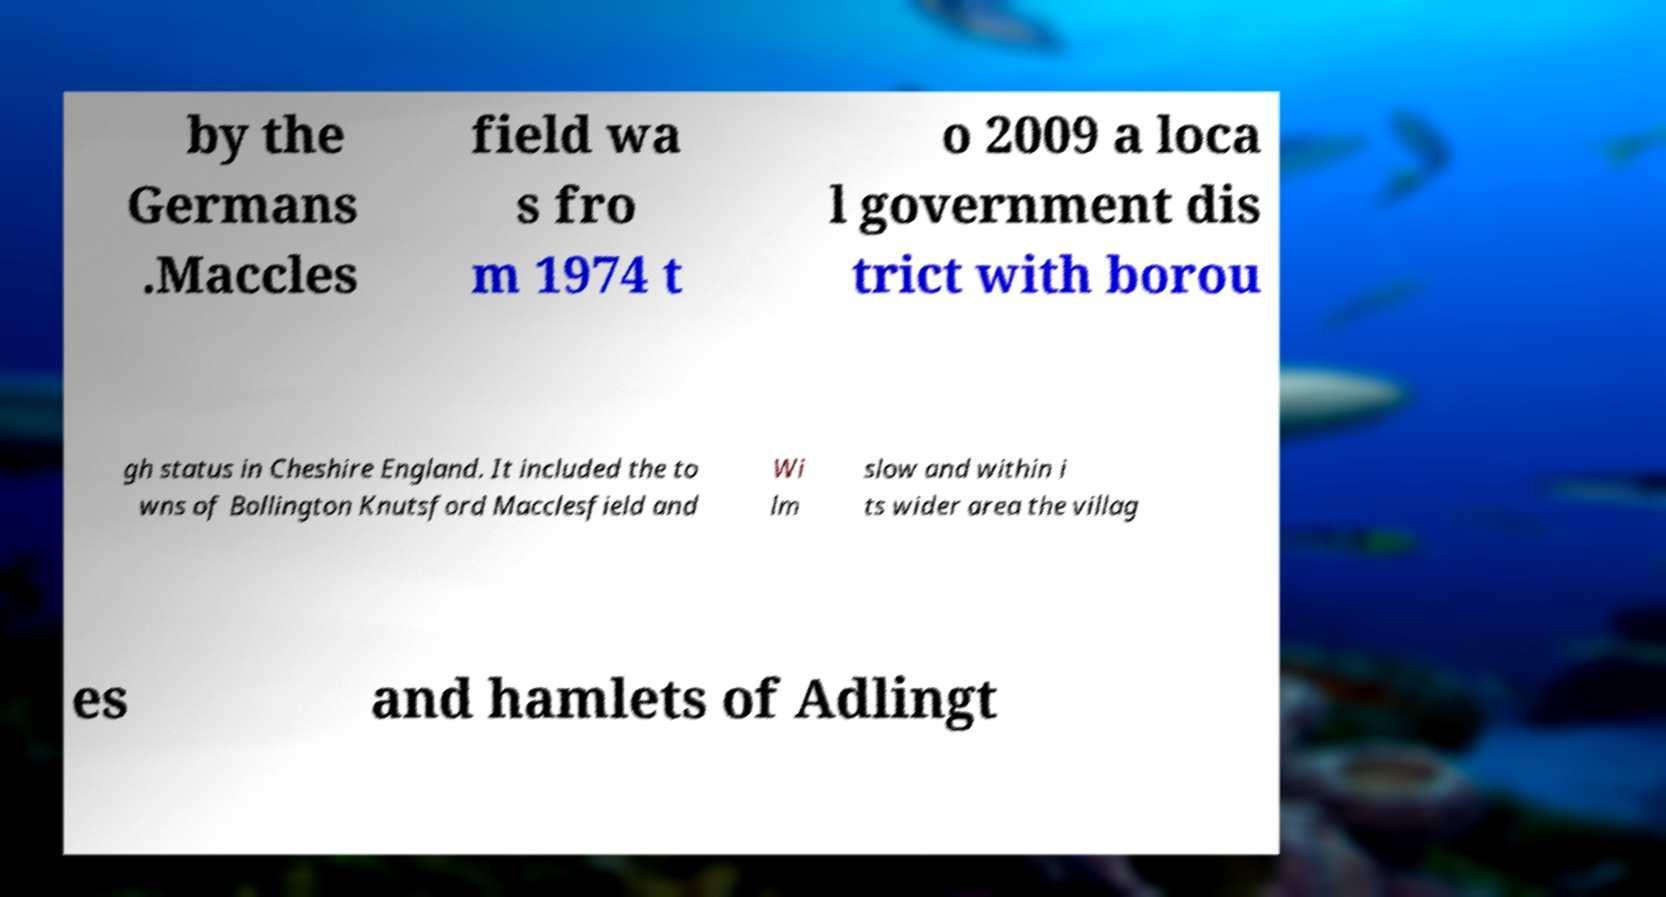Please read and relay the text visible in this image. What does it say? by the Germans .Maccles field wa s fro m 1974 t o 2009 a loca l government dis trict with borou gh status in Cheshire England. It included the to wns of Bollington Knutsford Macclesfield and Wi lm slow and within i ts wider area the villag es and hamlets of Adlingt 